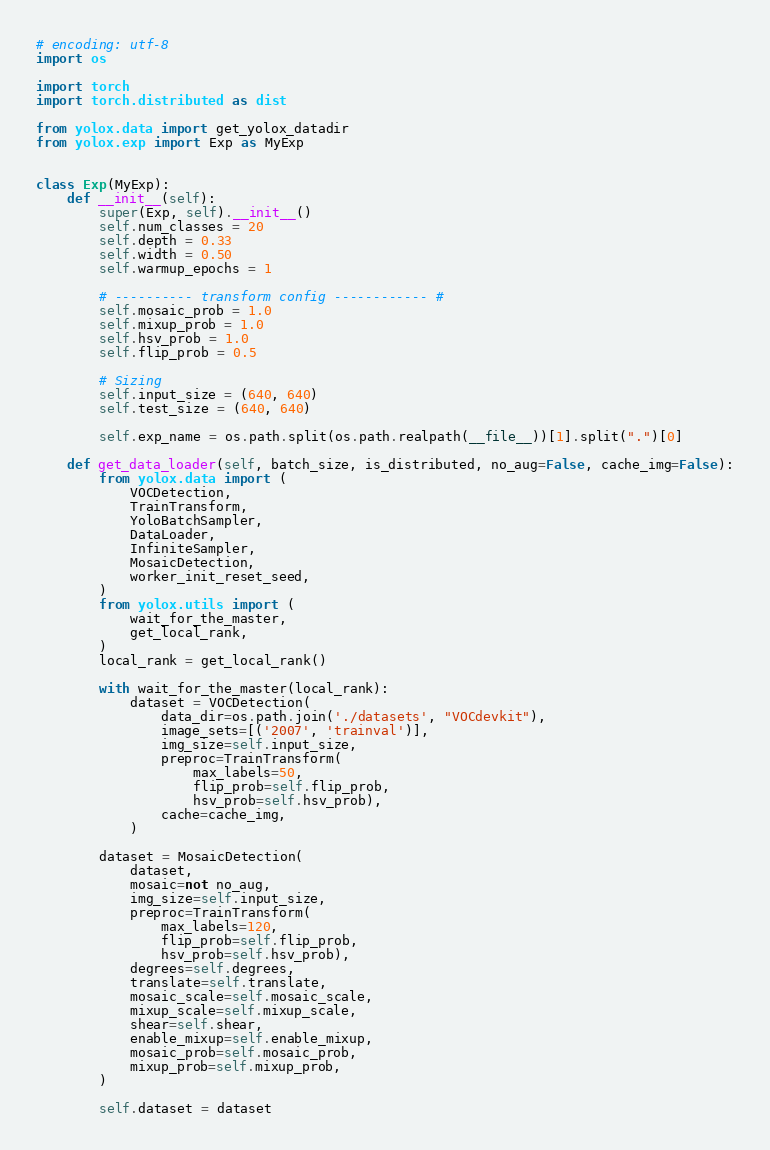<code> <loc_0><loc_0><loc_500><loc_500><_Python_># encoding: utf-8
import os

import torch
import torch.distributed as dist

from yolox.data import get_yolox_datadir
from yolox.exp import Exp as MyExp


class Exp(MyExp):
    def __init__(self):
        super(Exp, self).__init__()
        self.num_classes = 20
        self.depth = 0.33
        self.width = 0.50
        self.warmup_epochs = 1

        # ---------- transform config ------------ #
        self.mosaic_prob = 1.0
        self.mixup_prob = 1.0
        self.hsv_prob = 1.0
        self.flip_prob = 0.5

        # Sizing
        self.input_size = (640, 640)
        self.test_size = (640, 640)

        self.exp_name = os.path.split(os.path.realpath(__file__))[1].split(".")[0]

    def get_data_loader(self, batch_size, is_distributed, no_aug=False, cache_img=False):
        from yolox.data import (
            VOCDetection,
            TrainTransform,
            YoloBatchSampler,
            DataLoader,
            InfiniteSampler,
            MosaicDetection,
            worker_init_reset_seed,
        )
        from yolox.utils import (
            wait_for_the_master,
            get_local_rank,
        )
        local_rank = get_local_rank()

        with wait_for_the_master(local_rank):
            dataset = VOCDetection(
                data_dir=os.path.join('./datasets', "VOCdevkit"),
                image_sets=[('2007', 'trainval')],
                img_size=self.input_size,
                preproc=TrainTransform(
                    max_labels=50,
                    flip_prob=self.flip_prob,
                    hsv_prob=self.hsv_prob),
                cache=cache_img,
            )

        dataset = MosaicDetection(
            dataset,
            mosaic=not no_aug,
            img_size=self.input_size,
            preproc=TrainTransform(
                max_labels=120,
                flip_prob=self.flip_prob,
                hsv_prob=self.hsv_prob),
            degrees=self.degrees,
            translate=self.translate,
            mosaic_scale=self.mosaic_scale,
            mixup_scale=self.mixup_scale,
            shear=self.shear,
            enable_mixup=self.enable_mixup,
            mosaic_prob=self.mosaic_prob,
            mixup_prob=self.mixup_prob,
        )

        self.dataset = dataset
</code> 